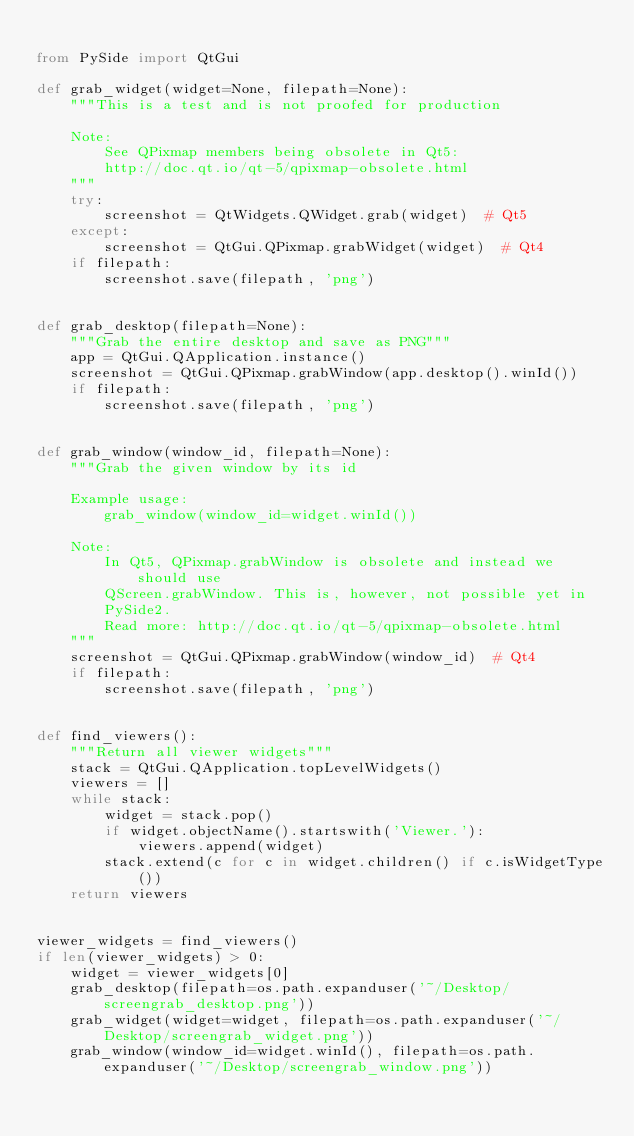Convert code to text. <code><loc_0><loc_0><loc_500><loc_500><_Python_>
from PySide import QtGui

def grab_widget(widget=None, filepath=None):
    """This is a test and is not proofed for production

    Note:
        See QPixmap members being obsolete in Qt5:
        http://doc.qt.io/qt-5/qpixmap-obsolete.html
    """
    try:
        screenshot = QtWidgets.QWidget.grab(widget)  # Qt5
    except:
        screenshot = QtGui.QPixmap.grabWidget(widget)  # Qt4
    if filepath:
        screenshot.save(filepath, 'png')


def grab_desktop(filepath=None):
    """Grab the entire desktop and save as PNG"""
    app = QtGui.QApplication.instance()
    screenshot = QtGui.QPixmap.grabWindow(app.desktop().winId())
    if filepath:
        screenshot.save(filepath, 'png')


def grab_window(window_id, filepath=None):
    """Grab the given window by its id

    Example usage:
        grab_window(window_id=widget.winId())

    Note:
        In Qt5, QPixmap.grabWindow is obsolete and instead we should use
        QScreen.grabWindow. This is, however, not possible yet in
        PySide2.
        Read more: http://doc.qt.io/qt-5/qpixmap-obsolete.html
    """
    screenshot = QtGui.QPixmap.grabWindow(window_id)  # Qt4
    if filepath:
        screenshot.save(filepath, 'png')


def find_viewers():
    """Return all viewer widgets"""
    stack = QtGui.QApplication.topLevelWidgets()
    viewers = []
    while stack:
        widget = stack.pop()
        if widget.objectName().startswith('Viewer.'):
            viewers.append(widget)
        stack.extend(c for c in widget.children() if c.isWidgetType())
    return viewers


viewer_widgets = find_viewers()
if len(viewer_widgets) > 0:
    widget = viewer_widgets[0]
    grab_desktop(filepath=os.path.expanduser('~/Desktop/screengrab_desktop.png'))
    grab_widget(widget=widget, filepath=os.path.expanduser('~/Desktop/screengrab_widget.png'))
    grab_window(window_id=widget.winId(), filepath=os.path.expanduser('~/Desktop/screengrab_window.png'))</code> 